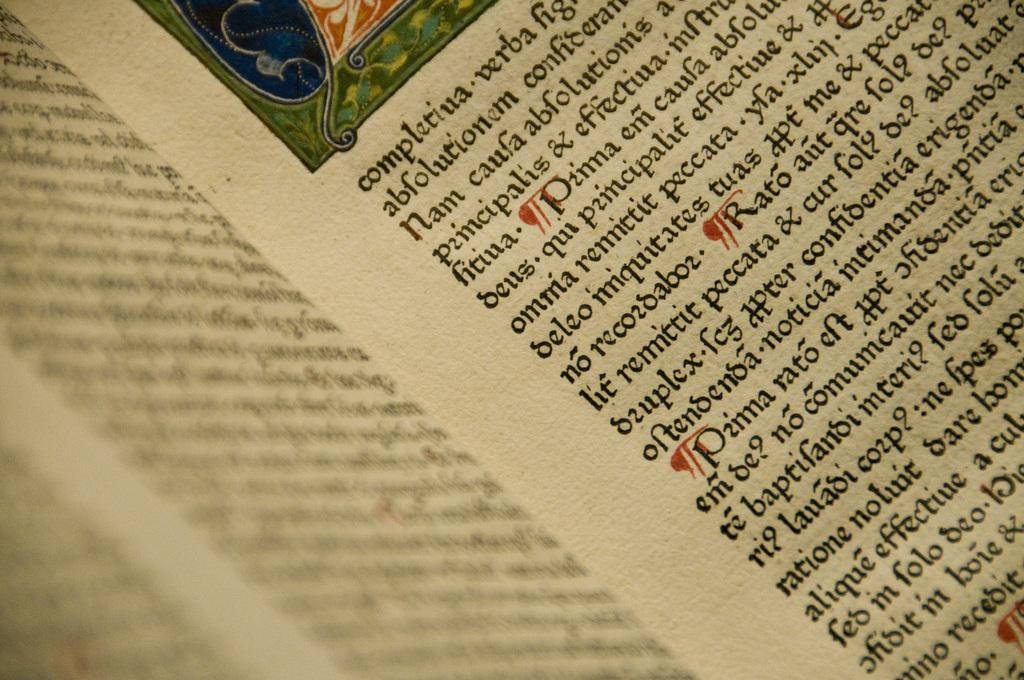<image>
Present a compact description of the photo's key features. An open book reveals writing in a foreign language. 